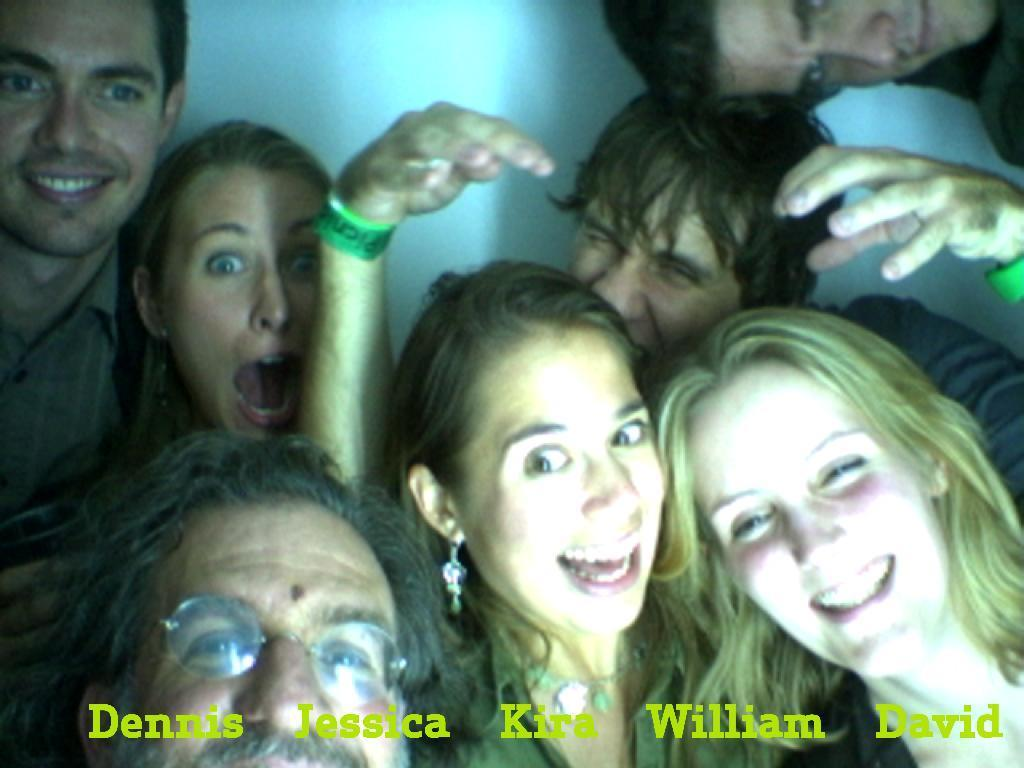How many people are present in the image? There are three women and four men in the image, making a total of seven people. What can be seen in the background of the image? There is a wall visible in the background of the image. Is there any text or marking on the image? Yes, there is a watermark at the bottom of the image. What type of pleasure can be seen on the canvas in the image? There is no canvas or pleasure present in the image; it features seven people and a wall in the background. 